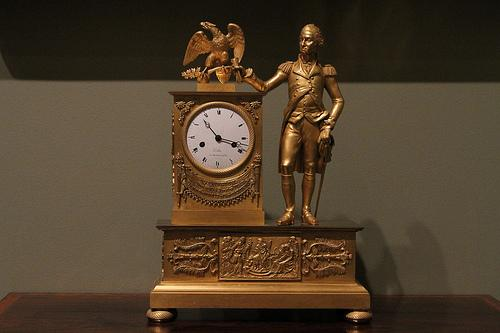Can you point out any specific decorations on the clock and its surroundings? The clock features an eagle perched on top, a white clock face with black Roman numerals and hands, golden decorations around the clock, and a golden statue of a soldier at its base holding a sword. Please provide a brief description of the table in the image. The table is a brown wooden table, dark in color, with a large flat top surface that supports the decorative clock. Identify the colors of the wall, clock face, and clock hands. The wall is tan or gray, the clock face is white, and the clock hands are black. Identify and describe any shadows present in the image. There are shadows of the decorative clock and its intricate designs cast on the wall and the table, appearing darker on the gray wall and lighter on the wooden table. How would you rate the image quality in terms of clarity and composition? The image quality is fairly high, with clear details and a well-composed arrangement of elements, showcasing the clock and table effectively against the wall. What type of clock is primarily displayed in the image? A gold colored decorative clock with an eagle perched on the top and a small golden statue of a soldier at its base. Count the number of visible objects in the image. There are at least 12 visible objects, including the clock, table, eagle, soldier statue, decorations, clock hands, clock face, and various shadows. Determine the reasoning behind the clock being considered patriotic. The clock features symbols of American patriotism, such as the eagle perched on top and the golden soldier statue at its base, as well as a design reminiscent of older styles. Analyze the interactions between the objects present in the image. The primary interaction is between the clock and its various components, like the eagle and soldier, which together create a cohesive design. The clock also interacts with the table as it rests on it, and both objects cast shadows on the wall and each other. Evaluate the overall sentiment or mood conveyed by the image. The image conveys a nostalgic, patriotic, and somewhat old-fashioned sentiment, as the clock and its decorations showcase traditional design elements and national symbols. 